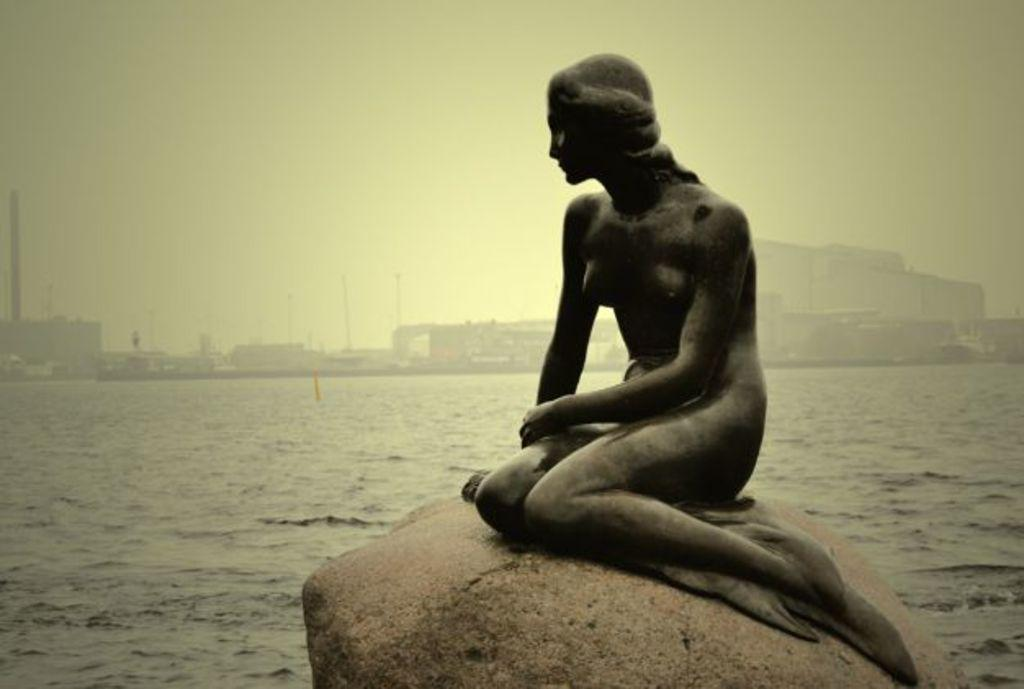What is the main subject in the center of the image? There is a sculpture on a rock in the center of the image. What can be seen in the background of the image? There is a river, buildings, and poles in the background of the image. What is visible at the top of the image? The sky is visible at the top of the image. How does the sculpture express its feelings of hate towards the river in the image? The sculpture does not express any feelings, as it is an inanimate object. Additionally, there is no mention of the sculpture expressing hate towards the river in the image. 